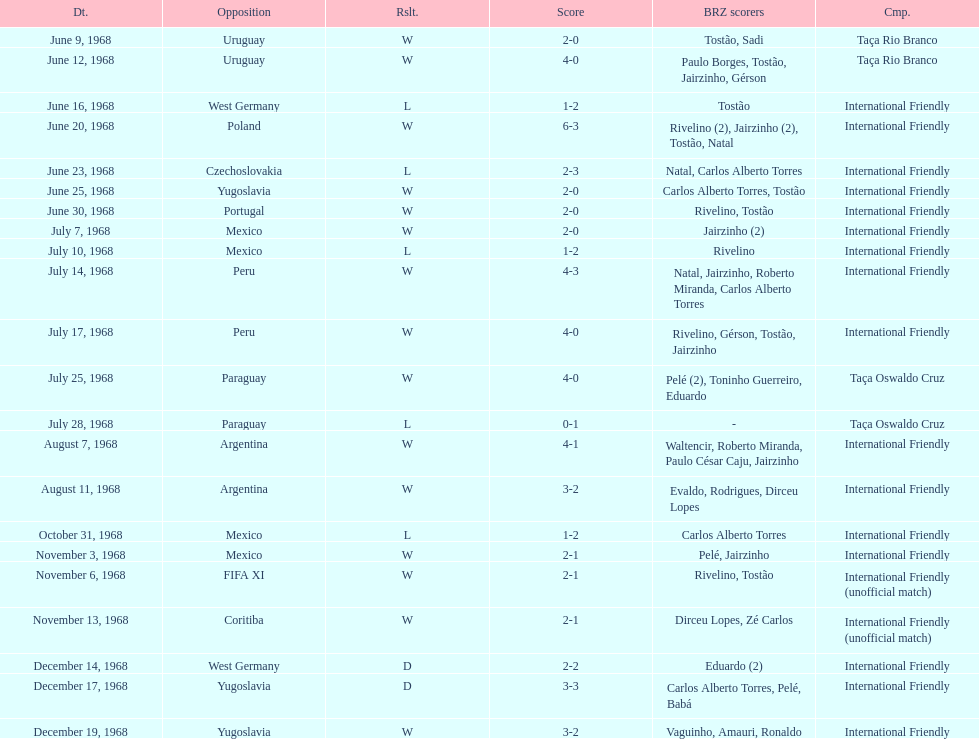Number of losses 5. 